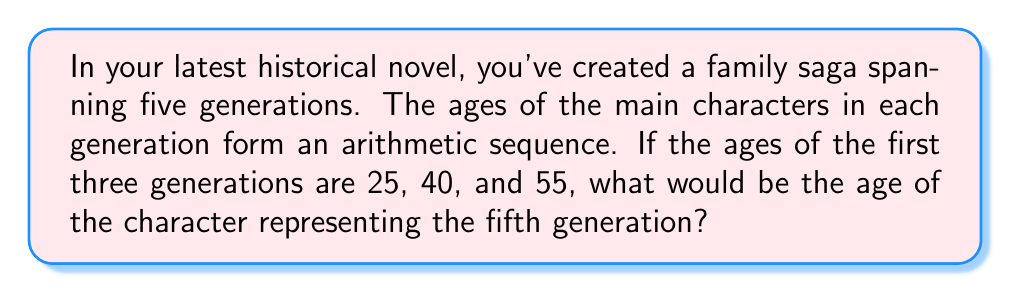Provide a solution to this math problem. Let's approach this step-by-step:

1) First, we need to identify the arithmetic sequence. An arithmetic sequence has a constant difference between each term. Let's call this common difference $d$.

2) We can calculate $d$ by subtracting any term from the subsequent term:

   $d = 40 - 25 = 55 - 40 = 15$

3) Now we can represent our sequence algebraically:
   
   $a_n = a_1 + (n-1)d$

   Where $a_n$ is the $n$th term, $a_1$ is the first term (25 in this case), and $n$ is the position in the sequence.

4) We're looking for the 5th term, so $n = 5$:

   $a_5 = 25 + (5-1)15$

5) Let's solve this:
   
   $a_5 = 25 + (4)(15)$
   $a_5 = 25 + 60$
   $a_5 = 85$

Therefore, the age of the character representing the fifth generation would be 85.
Answer: 85 